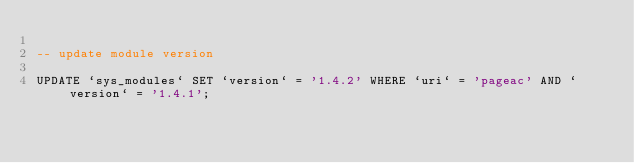<code> <loc_0><loc_0><loc_500><loc_500><_SQL_>
-- update module version

UPDATE `sys_modules` SET `version` = '1.4.2' WHERE `uri` = 'pageac' AND `version` = '1.4.1';

</code> 